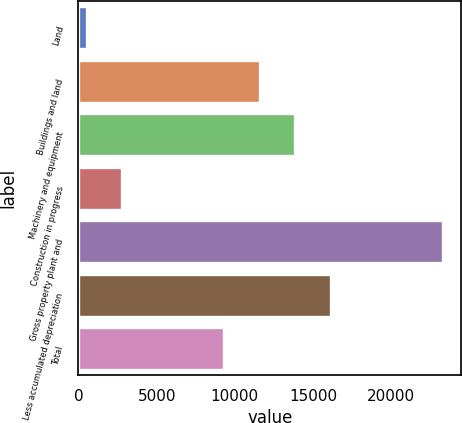<chart> <loc_0><loc_0><loc_500><loc_500><bar_chart><fcel>Land<fcel>Buildings and land<fcel>Machinery and equipment<fcel>Construction in progress<fcel>Gross property plant and<fcel>Less accumulated depreciation<fcel>Total<nl><fcel>526<fcel>11591<fcel>13869<fcel>2804<fcel>23306<fcel>16147<fcel>9313<nl></chart> 